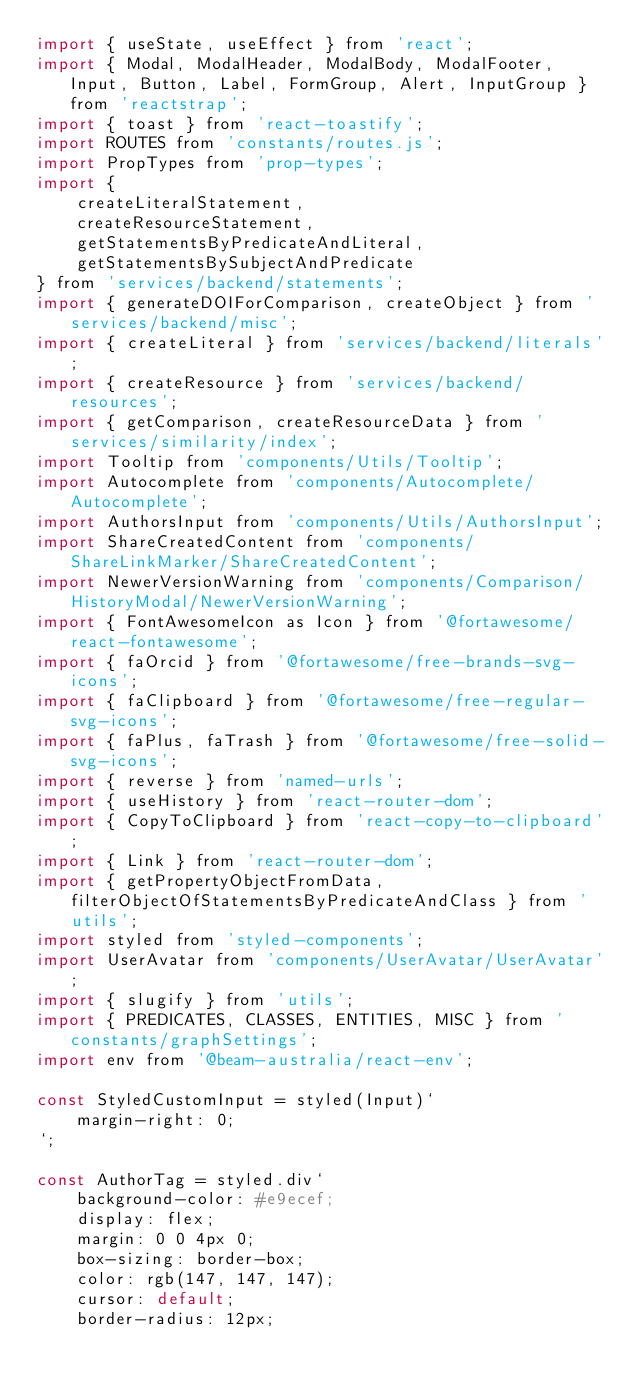<code> <loc_0><loc_0><loc_500><loc_500><_JavaScript_>import { useState, useEffect } from 'react';
import { Modal, ModalHeader, ModalBody, ModalFooter, Input, Button, Label, FormGroup, Alert, InputGroup } from 'reactstrap';
import { toast } from 'react-toastify';
import ROUTES from 'constants/routes.js';
import PropTypes from 'prop-types';
import {
    createLiteralStatement,
    createResourceStatement,
    getStatementsByPredicateAndLiteral,
    getStatementsBySubjectAndPredicate
} from 'services/backend/statements';
import { generateDOIForComparison, createObject } from 'services/backend/misc';
import { createLiteral } from 'services/backend/literals';
import { createResource } from 'services/backend/resources';
import { getComparison, createResourceData } from 'services/similarity/index';
import Tooltip from 'components/Utils/Tooltip';
import Autocomplete from 'components/Autocomplete/Autocomplete';
import AuthorsInput from 'components/Utils/AuthorsInput';
import ShareCreatedContent from 'components/ShareLinkMarker/ShareCreatedContent';
import NewerVersionWarning from 'components/Comparison/HistoryModal/NewerVersionWarning';
import { FontAwesomeIcon as Icon } from '@fortawesome/react-fontawesome';
import { faOrcid } from '@fortawesome/free-brands-svg-icons';
import { faClipboard } from '@fortawesome/free-regular-svg-icons';
import { faPlus, faTrash } from '@fortawesome/free-solid-svg-icons';
import { reverse } from 'named-urls';
import { useHistory } from 'react-router-dom';
import { CopyToClipboard } from 'react-copy-to-clipboard';
import { Link } from 'react-router-dom';
import { getPropertyObjectFromData, filterObjectOfStatementsByPredicateAndClass } from 'utils';
import styled from 'styled-components';
import UserAvatar from 'components/UserAvatar/UserAvatar';
import { slugify } from 'utils';
import { PREDICATES, CLASSES, ENTITIES, MISC } from 'constants/graphSettings';
import env from '@beam-australia/react-env';

const StyledCustomInput = styled(Input)`
    margin-right: 0;
`;

const AuthorTag = styled.div`
    background-color: #e9ecef;
    display: flex;
    margin: 0 0 4px 0;
    box-sizing: border-box;
    color: rgb(147, 147, 147);
    cursor: default;
    border-radius: 12px;</code> 